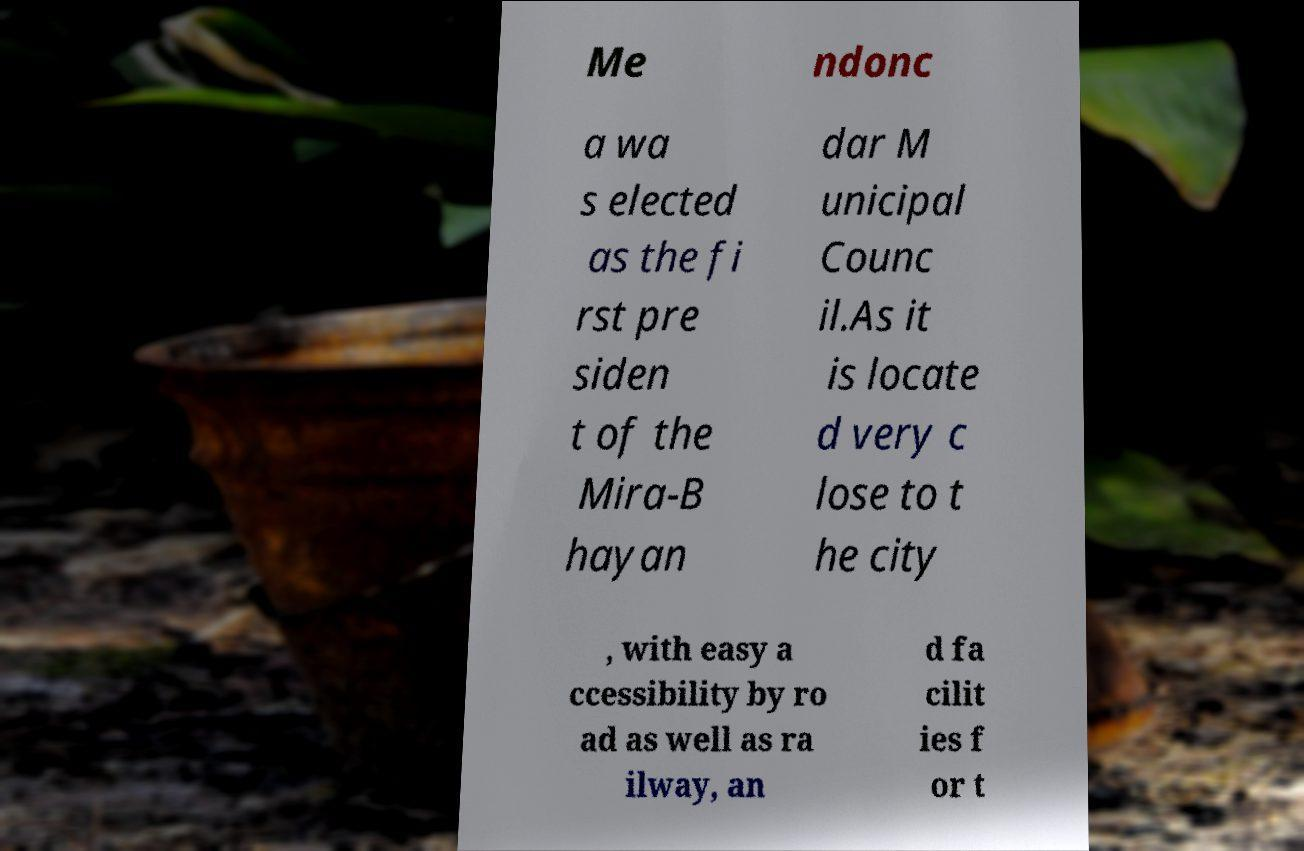Please read and relay the text visible in this image. What does it say? Me ndonc a wa s elected as the fi rst pre siden t of the Mira-B hayan dar M unicipal Counc il.As it is locate d very c lose to t he city , with easy a ccessibility by ro ad as well as ra ilway, an d fa cilit ies f or t 